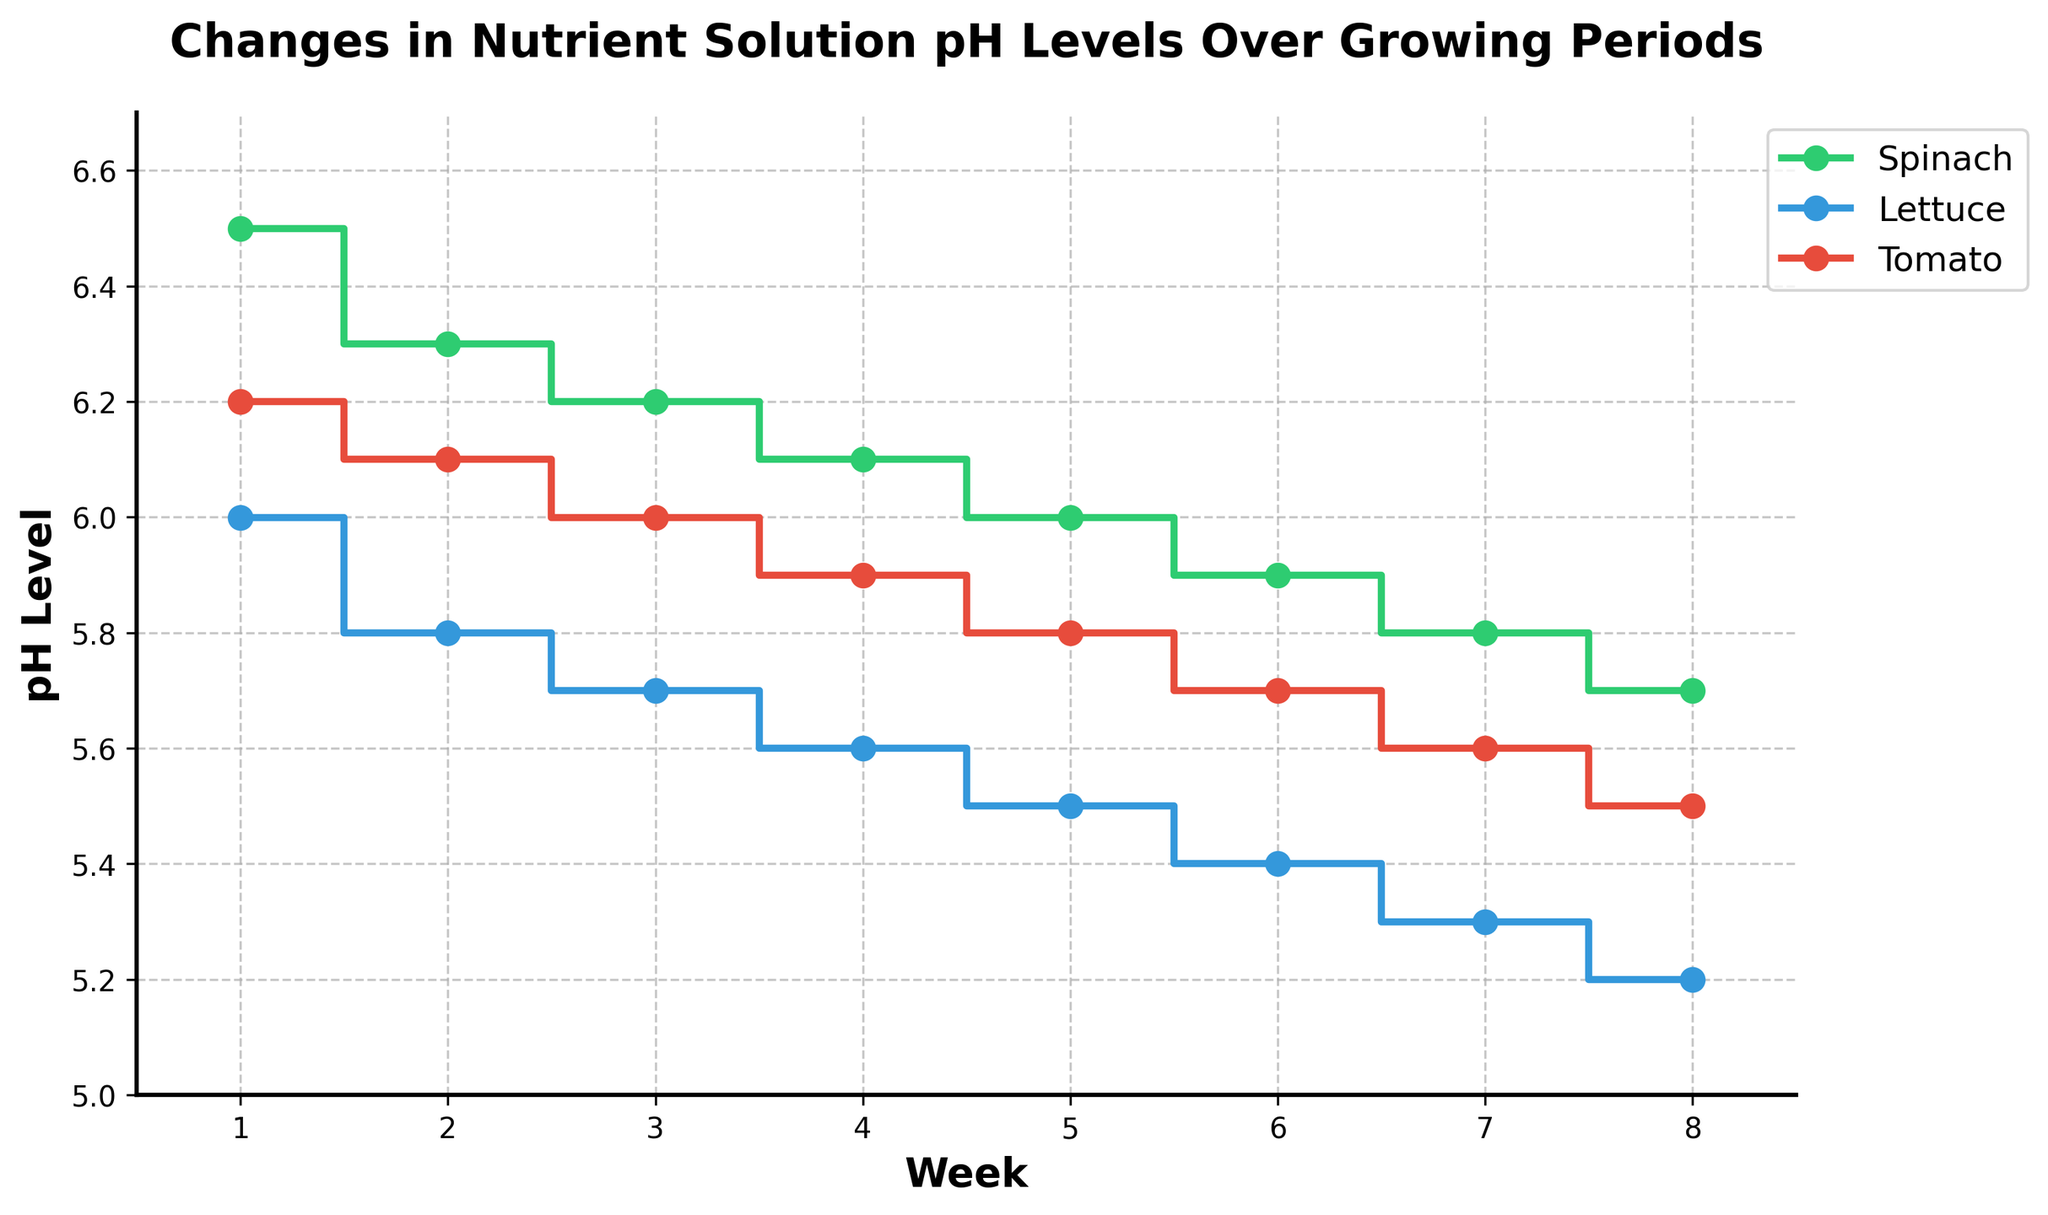How many weeks are represented in the figure? The x-axis of the plot shows the weeks, with markers starting from 1 to 8. This indicates that the data spans 8 weeks.
Answer: 8 Which plant has the lowest pH value at Week 1? At Week 1, Spinach has a pH of 6.5, Lettuce has a pH of 6.0, and Tomato has a pH of 6.2. Among these, Lettuce has the lowest pH value.
Answer: Lettuce By how much did the pH level of Spinach decrease from Week 1 to Week 8? At Week 1, the pH level of Spinach is 6.5. At Week 8, it is 5.7. The decrease is calculated as 6.5 - 5.7 = 0.8.
Answer: 0.8 Which plant shows the most consistent decrease in pH levels over the growing periods? Examining the plot, Spinach, Lettuce, and Tomato all show a decrease in pH levels, but Lettuce decreases consistently by approximately 0.1 every week.
Answer: Lettuce What is the pH level of Tomato in Week 5? Refer to the plot and find the data point corresponding to Tomato in Week 5. The pH level of Tomato in Week 5 is 5.8.
Answer: 5.8 What is the difference in pH levels between Spinach and Tomato in Week 3? In Week 3, Spinach has a pH level of 6.2 and Tomato has a pH level of 6.0. The difference is 6.2 - 6.0 = 0.2.
Answer: 0.2 Between which two consecutive weeks is the largest drop in pH for Lettuce observed? Analyzing the plot, the largest drop for Lettuce is between Week 1 and Week 2, where the pH drops from 6.0 to 5.8, amounting to a 0.2 decrease.
Answer: Week 1 to Week 2 Does any plant have a pH level of exactly 6.0 at any point during the 8 weeks? By examining the plot for all plants, Spinach has a pH level of 6.0 in Week 5, and no other plant hits exactly 6.0 during the growing period.
Answer: Yes If the ideal pH range for growing Lettuce is 5.5 to 6.5, how many weeks did Lettuce remain within this range? From the plot, Lettuce has a pH of 6.0, 5.8, 5.7, 5.6, and 5.5 in the first 5 weeks, all of which are within the 5.5 to 6.5 range. Therefore, Lettuce stayed within this ideal range for 5 weeks.
Answer: 5 